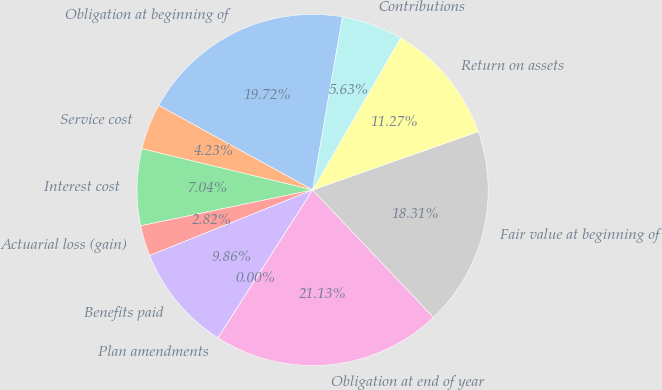Convert chart to OTSL. <chart><loc_0><loc_0><loc_500><loc_500><pie_chart><fcel>Obligation at beginning of<fcel>Service cost<fcel>Interest cost<fcel>Actuarial loss (gain)<fcel>Benefits paid<fcel>Plan amendments<fcel>Obligation at end of year<fcel>Fair value at beginning of<fcel>Return on assets<fcel>Contributions<nl><fcel>19.72%<fcel>4.23%<fcel>7.04%<fcel>2.82%<fcel>9.86%<fcel>0.0%<fcel>21.13%<fcel>18.31%<fcel>11.27%<fcel>5.63%<nl></chart> 